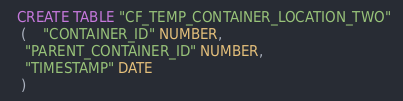Convert code to text. <code><loc_0><loc_0><loc_500><loc_500><_SQL_>
  CREATE TABLE "CF_TEMP_CONTAINER_LOCATION_TWO" 
   (	"CONTAINER_ID" NUMBER, 
	"PARENT_CONTAINER_ID" NUMBER, 
	"TIMESTAMP" DATE
   ) </code> 